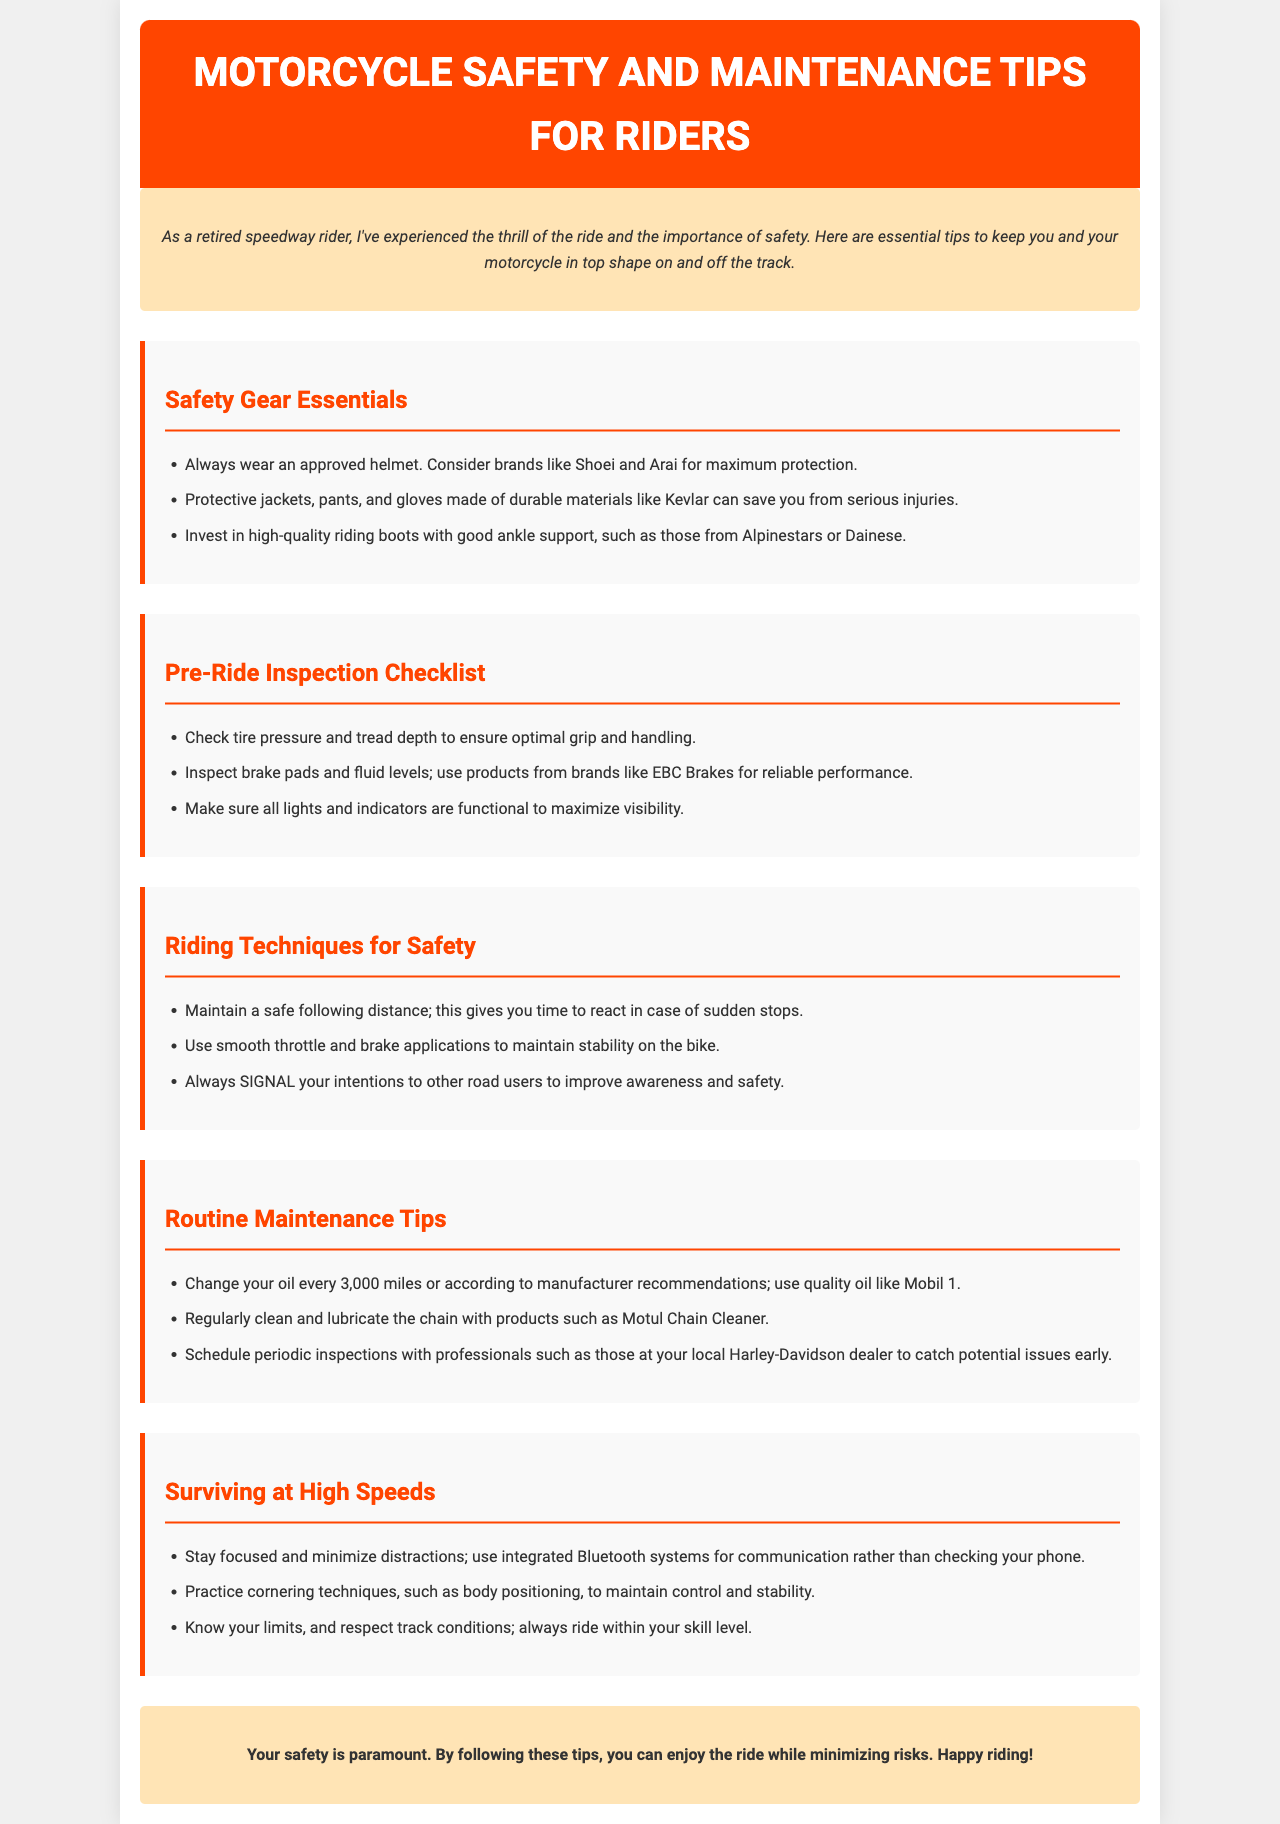What is the title of the document? The title is found prominently at the top of the brochure and indicates its main focus.
Answer: Motorcycle Safety and Maintenance Tips for Riders What type of helmet is recommended? The recommendation for helmets is specified in the Safety Gear Essentials section, including specific brands known for safety.
Answer: Approved helmet How often should you change your oil? The Routine Maintenance Tips section states the frequency of oil changes for maintaining motorcycle health.
Answer: Every 3,000 miles What material is suggested for protective gear? The document mentions durable materials suitable for protective gear in the Safety Gear Essentials section.
Answer: Kevlar What system should riders use for communication at high speeds? The document refers to a specific type of system for communication to minimize distractions while riding.
Answer: Integrated Bluetooth systems What is one key riding technique mentioned? The Riding Techniques for Safety section provides essential strategies to enhance safety while riding.
Answer: Maintain a safe following distance How often should periodic inspections be scheduled? The Routine Maintenance Tips section suggests regular intervals for maintenance checks, suggesting proactive safety.
Answer: Periodically What is a suggested product for chain cleaning? In the Routine Maintenance Tips section, a specific cleaning product is highlighted for maintaining the motorcycle chain.
Answer: Motul Chain Cleaner 